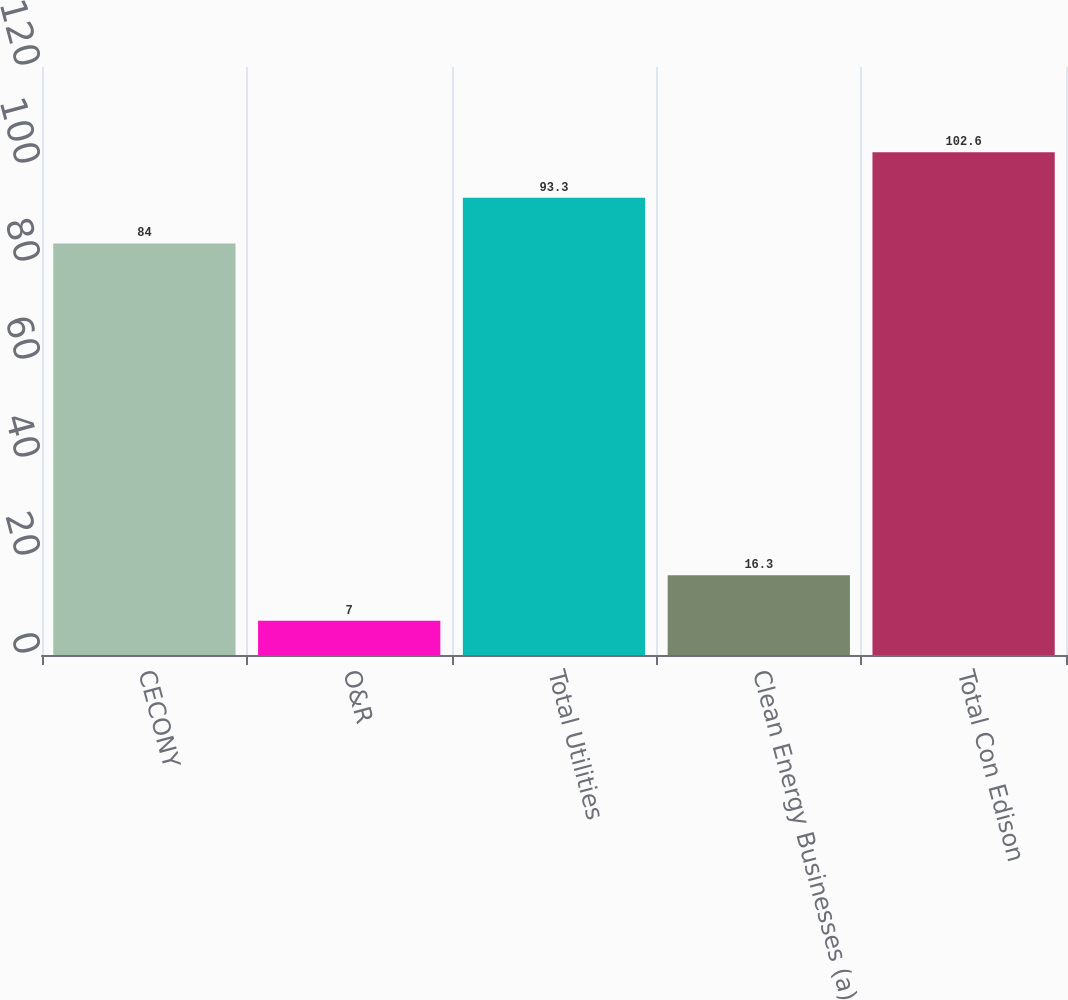Convert chart to OTSL. <chart><loc_0><loc_0><loc_500><loc_500><bar_chart><fcel>CECONY<fcel>O&R<fcel>Total Utilities<fcel>Clean Energy Businesses (a)<fcel>Total Con Edison<nl><fcel>84<fcel>7<fcel>93.3<fcel>16.3<fcel>102.6<nl></chart> 